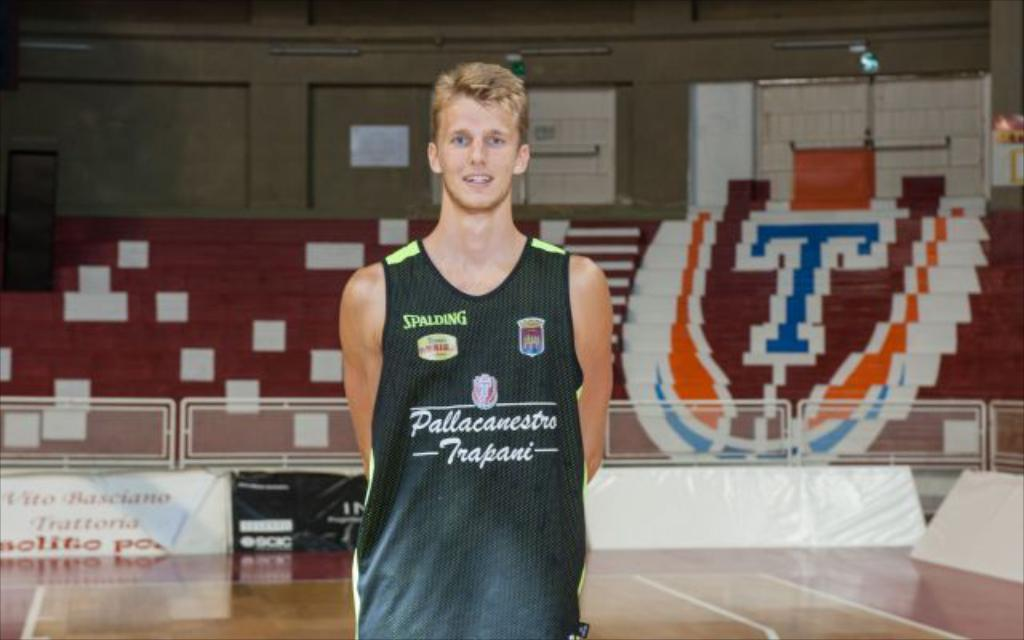<image>
Share a concise interpretation of the image provided. White basketball player for team Pallacanestro poses for the camera. 